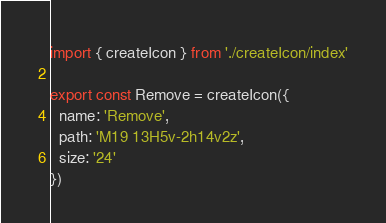Convert code to text. <code><loc_0><loc_0><loc_500><loc_500><_TypeScript_>
import { createIcon } from './createIcon/index'

export const Remove = createIcon({
  name: 'Remove',
  path: 'M19 13H5v-2h14v2z',
  size: '24'
})
</code> 